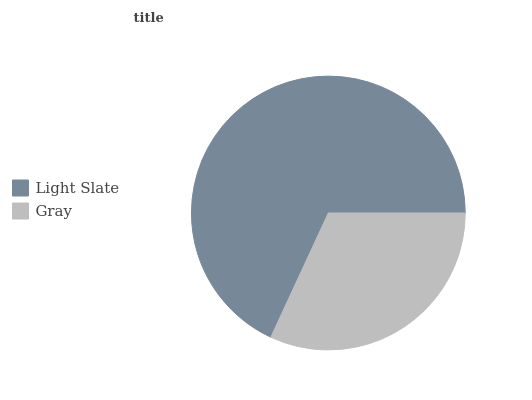Is Gray the minimum?
Answer yes or no. Yes. Is Light Slate the maximum?
Answer yes or no. Yes. Is Gray the maximum?
Answer yes or no. No. Is Light Slate greater than Gray?
Answer yes or no. Yes. Is Gray less than Light Slate?
Answer yes or no. Yes. Is Gray greater than Light Slate?
Answer yes or no. No. Is Light Slate less than Gray?
Answer yes or no. No. Is Light Slate the high median?
Answer yes or no. Yes. Is Gray the low median?
Answer yes or no. Yes. Is Gray the high median?
Answer yes or no. No. Is Light Slate the low median?
Answer yes or no. No. 